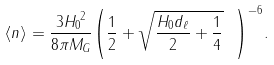Convert formula to latex. <formula><loc_0><loc_0><loc_500><loc_500>\langle n \rangle = \frac { 3 { H _ { 0 } } ^ { 2 } } { 8 \pi M _ { G } } { \left ( \frac { 1 } { 2 } + \sqrt { \frac { H _ { 0 } d _ { \ell } } { 2 } + \frac { 1 } { 4 } } \ \right ) } ^ { - 6 } .</formula> 